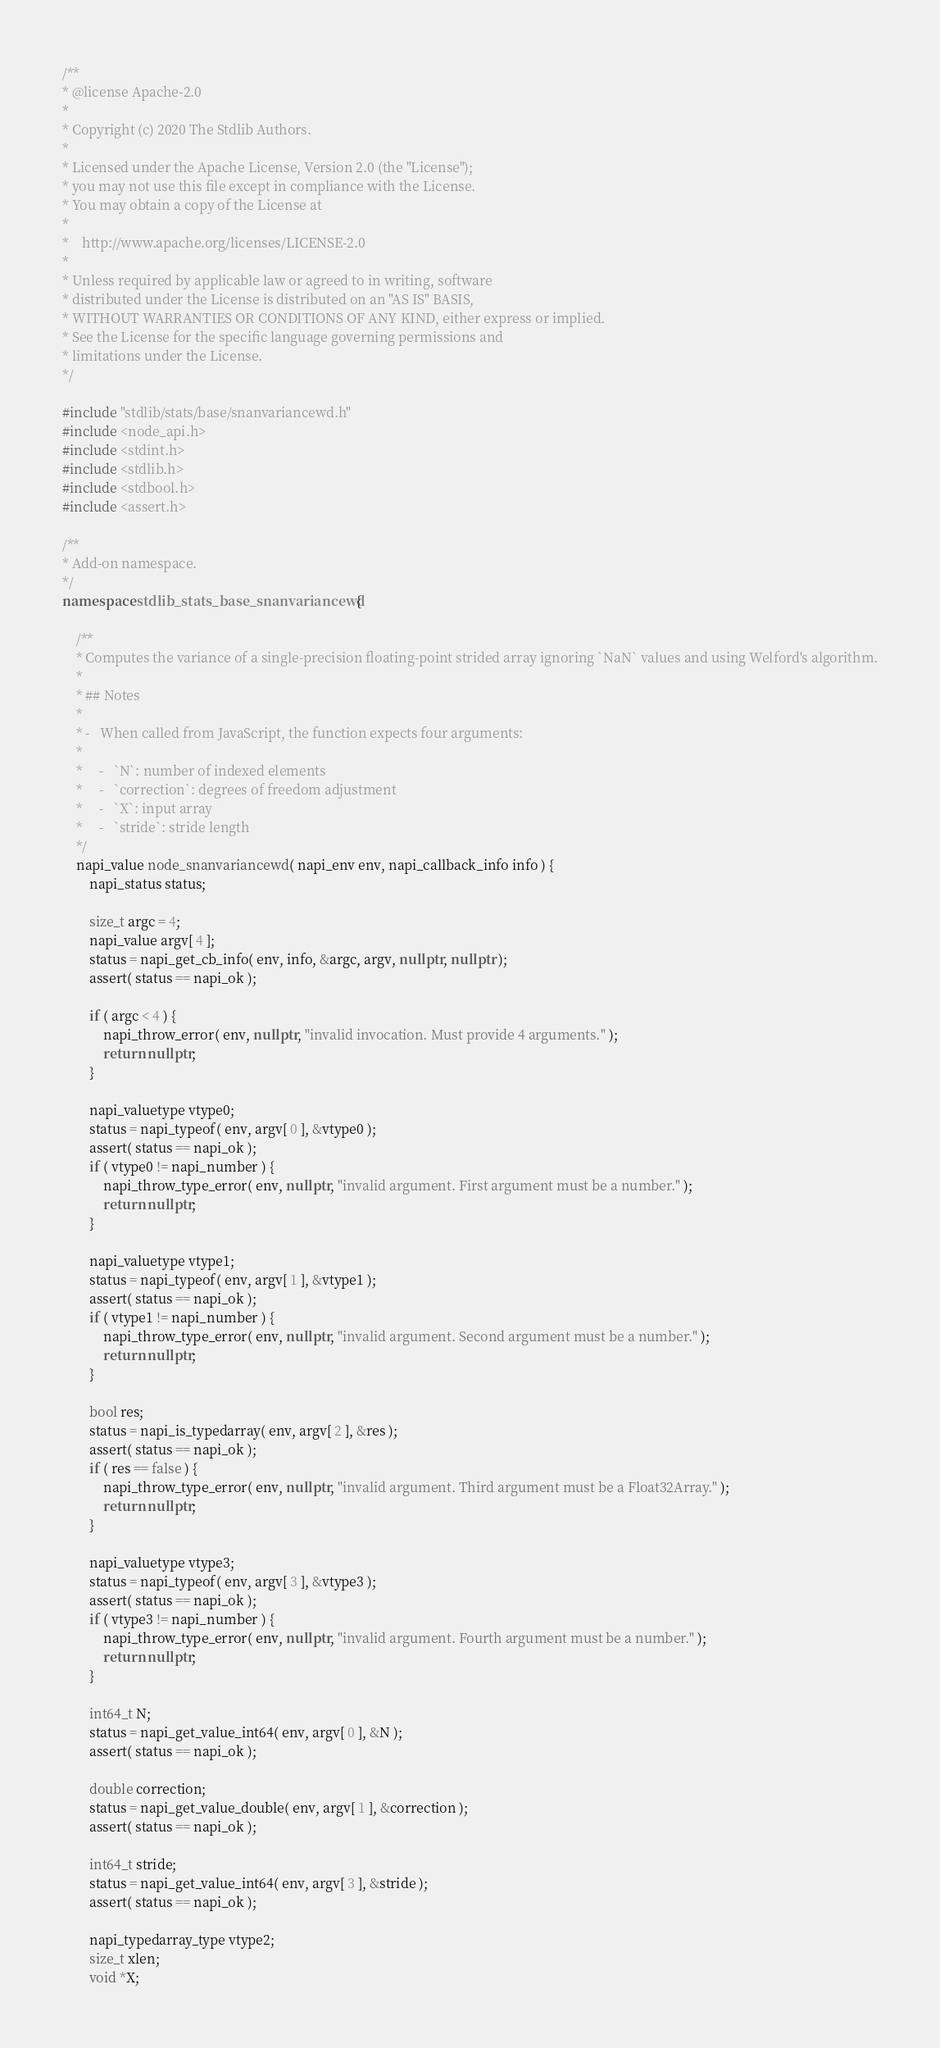Convert code to text. <code><loc_0><loc_0><loc_500><loc_500><_C++_>/**
* @license Apache-2.0
*
* Copyright (c) 2020 The Stdlib Authors.
*
* Licensed under the Apache License, Version 2.0 (the "License");
* you may not use this file except in compliance with the License.
* You may obtain a copy of the License at
*
*    http://www.apache.org/licenses/LICENSE-2.0
*
* Unless required by applicable law or agreed to in writing, software
* distributed under the License is distributed on an "AS IS" BASIS,
* WITHOUT WARRANTIES OR CONDITIONS OF ANY KIND, either express or implied.
* See the License for the specific language governing permissions and
* limitations under the License.
*/

#include "stdlib/stats/base/snanvariancewd.h"
#include <node_api.h>
#include <stdint.h>
#include <stdlib.h>
#include <stdbool.h>
#include <assert.h>

/**
* Add-on namespace.
*/
namespace stdlib_stats_base_snanvariancewd {

	/**
	* Computes the variance of a single-precision floating-point strided array ignoring `NaN` values and using Welford's algorithm.
	*
	* ## Notes
	*
	* -   When called from JavaScript, the function expects four arguments:
	*
	*     -   `N`: number of indexed elements
	*     -   `correction`: degrees of freedom adjustment
	*     -   `X`: input array
	*     -   `stride`: stride length
	*/
	napi_value node_snanvariancewd( napi_env env, napi_callback_info info ) {
		napi_status status;

		size_t argc = 4;
		napi_value argv[ 4 ];
		status = napi_get_cb_info( env, info, &argc, argv, nullptr, nullptr );
		assert( status == napi_ok );

		if ( argc < 4 ) {
			napi_throw_error( env, nullptr, "invalid invocation. Must provide 4 arguments." );
			return nullptr;
		}

		napi_valuetype vtype0;
		status = napi_typeof( env, argv[ 0 ], &vtype0 );
		assert( status == napi_ok );
		if ( vtype0 != napi_number ) {
			napi_throw_type_error( env, nullptr, "invalid argument. First argument must be a number." );
			return nullptr;
		}

		napi_valuetype vtype1;
		status = napi_typeof( env, argv[ 1 ], &vtype1 );
		assert( status == napi_ok );
		if ( vtype1 != napi_number ) {
			napi_throw_type_error( env, nullptr, "invalid argument. Second argument must be a number." );
			return nullptr;
		}

		bool res;
		status = napi_is_typedarray( env, argv[ 2 ], &res );
		assert( status == napi_ok );
		if ( res == false ) {
			napi_throw_type_error( env, nullptr, "invalid argument. Third argument must be a Float32Array." );
			return nullptr;
		}

		napi_valuetype vtype3;
		status = napi_typeof( env, argv[ 3 ], &vtype3 );
		assert( status == napi_ok );
		if ( vtype3 != napi_number ) {
			napi_throw_type_error( env, nullptr, "invalid argument. Fourth argument must be a number." );
			return nullptr;
		}

		int64_t N;
		status = napi_get_value_int64( env, argv[ 0 ], &N );
		assert( status == napi_ok );

		double correction;
		status = napi_get_value_double( env, argv[ 1 ], &correction );
		assert( status == napi_ok );

		int64_t stride;
		status = napi_get_value_int64( env, argv[ 3 ], &stride );
		assert( status == napi_ok );

		napi_typedarray_type vtype2;
		size_t xlen;
		void *X;</code> 